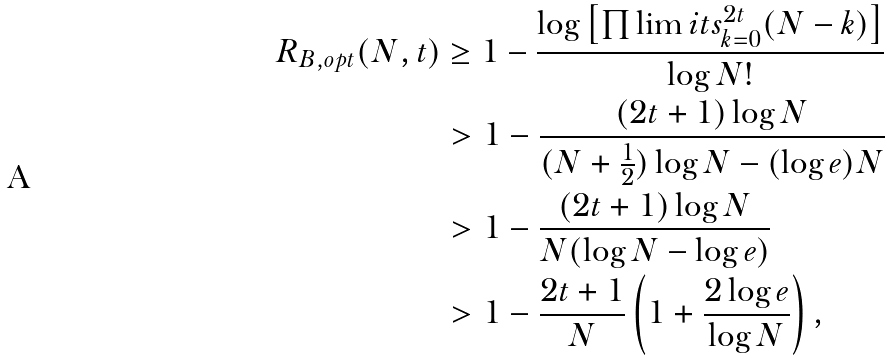Convert formula to latex. <formula><loc_0><loc_0><loc_500><loc_500>R _ { B , o p t } ( N , t ) & \geq 1 - \frac { \log \left [ \prod \lim i t s _ { k = 0 } ^ { 2 t } ( N - k ) \right ] } { \log N ! } \\ & > 1 - \frac { ( 2 t + 1 ) \log N } { ( N + \frac { 1 } { 2 } ) \log N - ( \log e ) N } \\ & > 1 - \frac { ( 2 t + 1 ) \log N } { N ( \log N - \log e ) } \\ & > 1 - \frac { 2 t + 1 } { N } \left ( 1 + \frac { 2 \log e } { \log N } \right ) , \\</formula> 